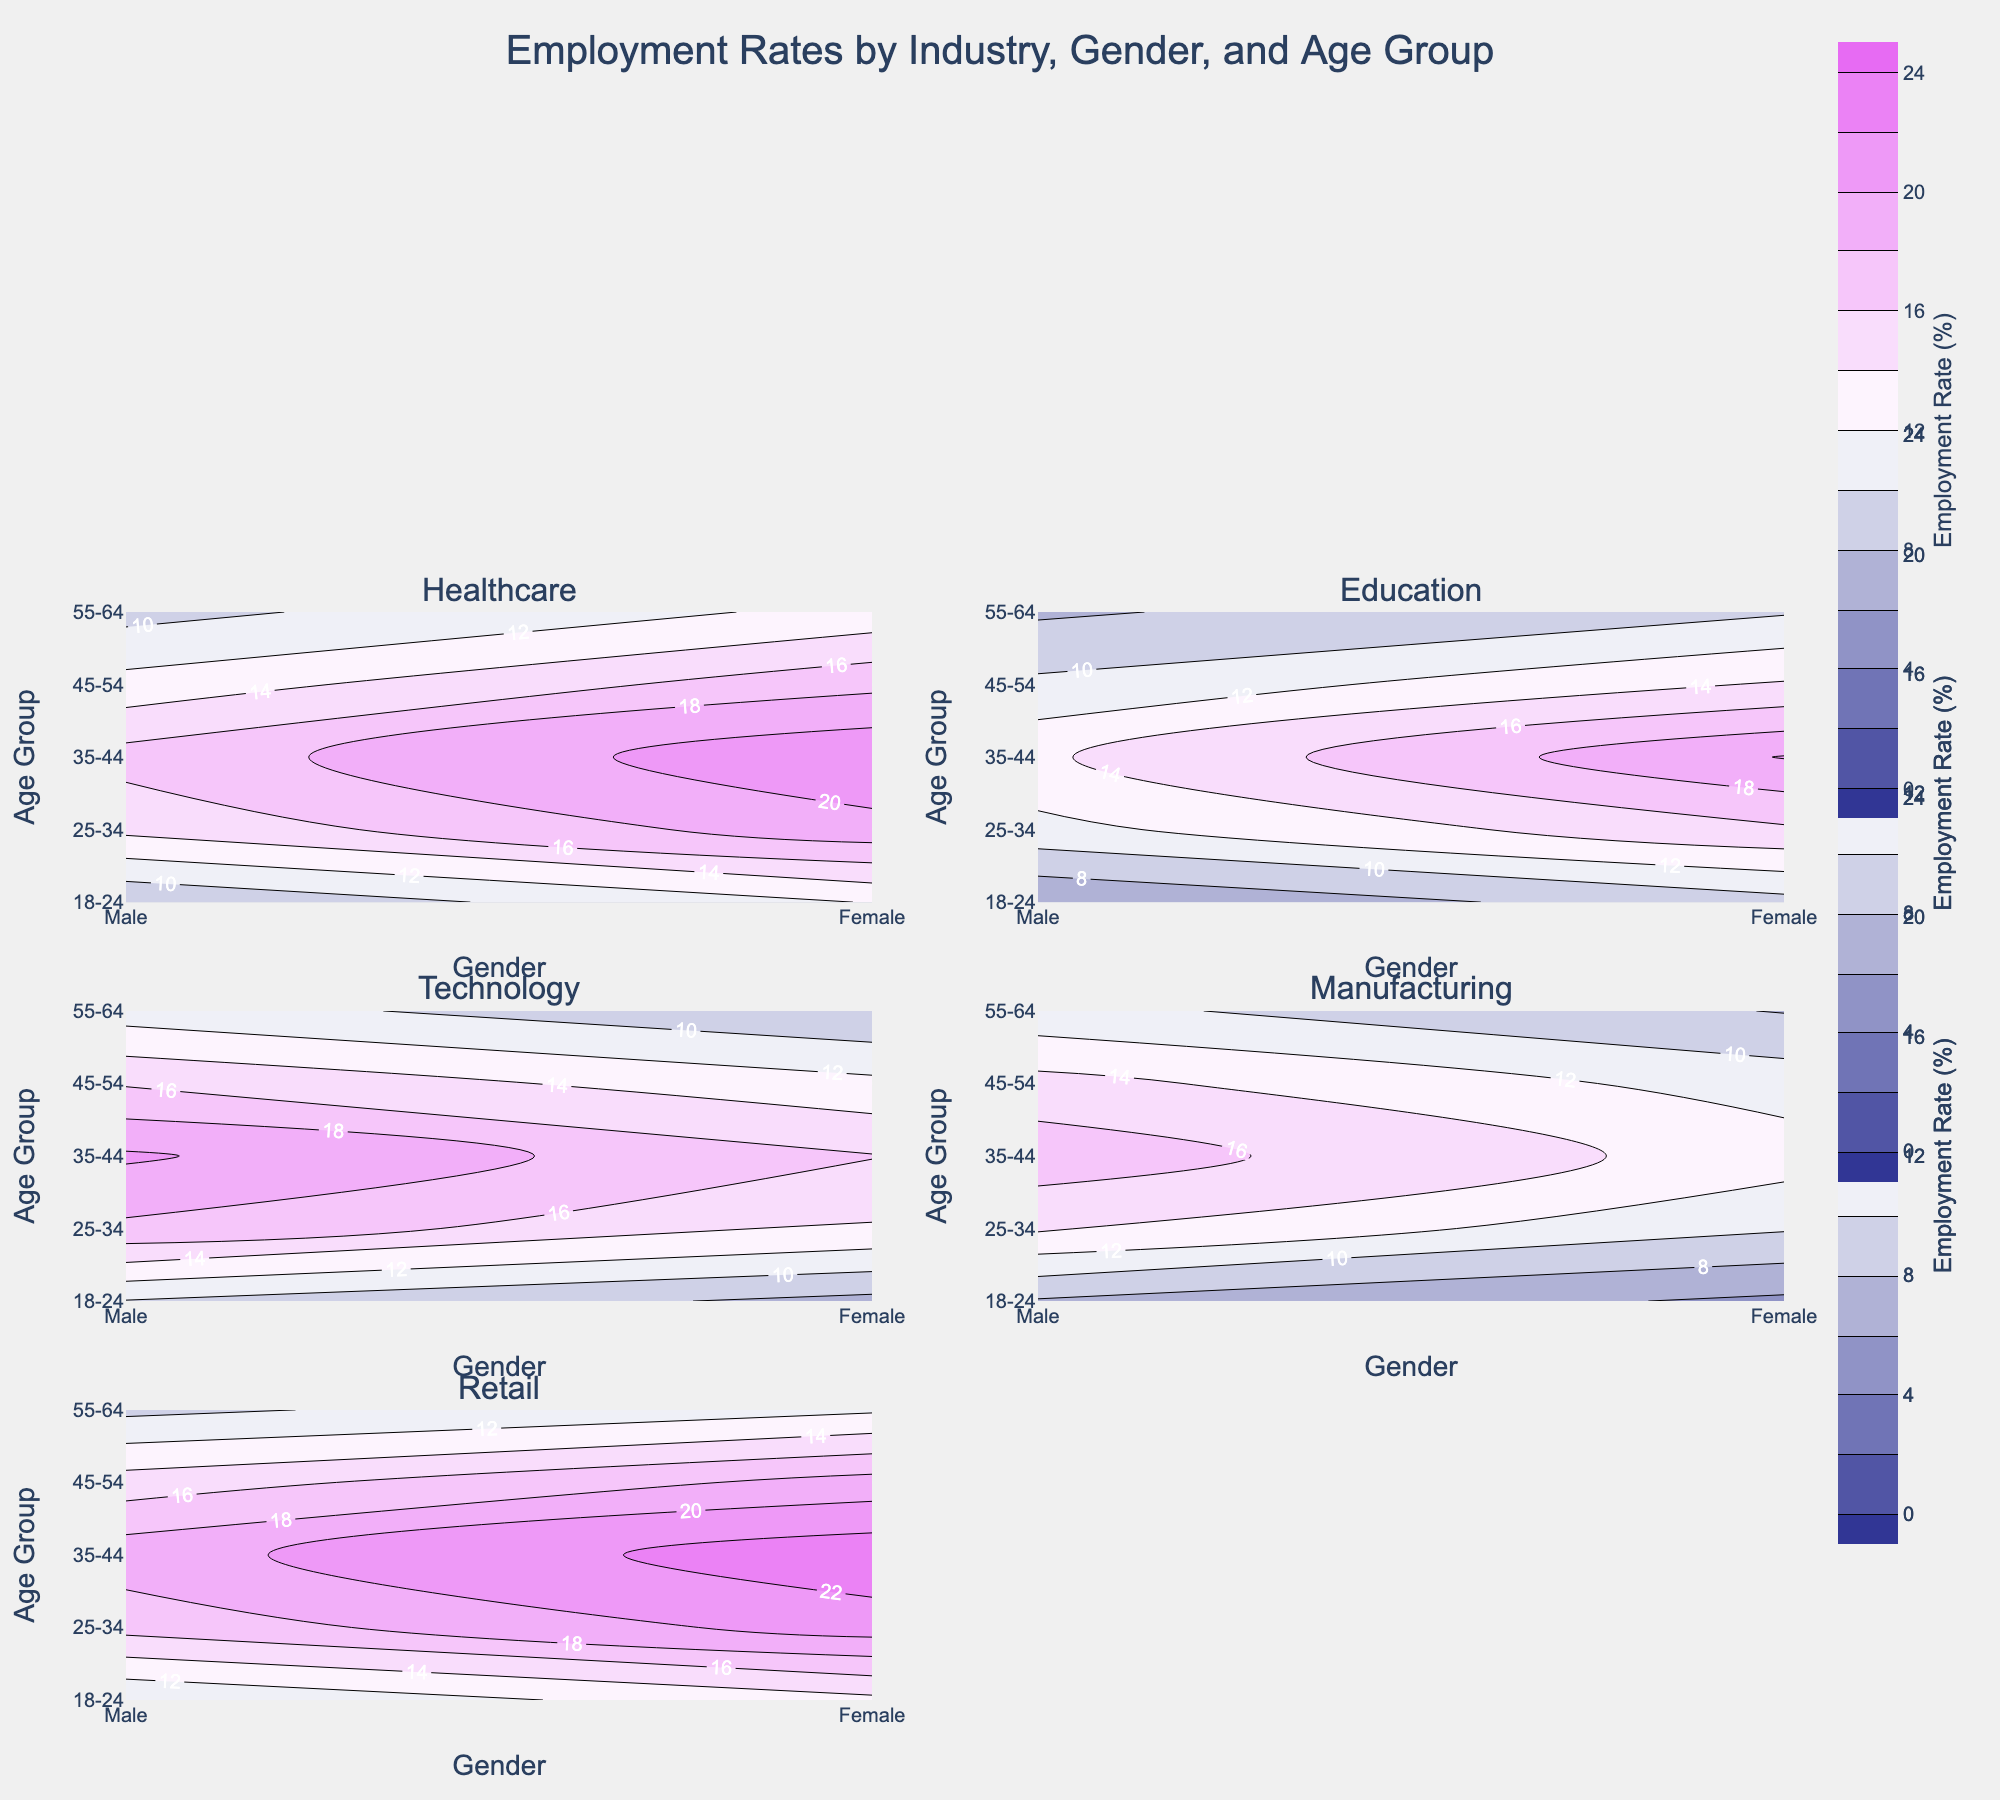How many age groups are displayed for each industry? The figure has five age groups labeled on the y-axis: 18-24, 25-34, 35-44, 45-54, and 55-64. Each subplot representing an industry shows these age groups for both genders.
Answer: 5 Which industry has the highest employment rate for females in the 35-44 age group? In the subplot for each industry, the contour showing the 35-44 age group and female gender shows the employment rate. The highest rate for this group is in the Retail industry where the employment rate for females is 23.4%.
Answer: Retail Which gender generally has a higher employment rate in Healthcare across all age groups? By comparing the contours for males and females across all age groups in the healthcare subplot, females consistently show higher employment rates than males.
Answer: Female Is the employment rate for males in the 25-34 age group higher in Technology or Manufacturing? Checking the contours for males in the 25-34 age group in the Technology and Manufacturing subplots, Technology has a rate of 17.6% while Manufacturing has a rate of 14.3%. Technology's rate is higher.
Answer: Technology What is the employment rate for males aged 45-54 in Education? In the Education subplot, for the age group of 45-54 and gender male, the employment rate can be read from the contour, which is 10.4%.
Answer: 10.4% Are there any industries where males aged 55-64 have lower employment rates than females of the same age group? By comparing the contours for the 55-64 age group, males, and females for each industry, it is observed that in both Technology and Manufacturing, males have a lower employment rate (11.0% vs. 8.1% in Technology and 10.6% vs. 7.9% in Manufacturing).
Answer: Yes Which industry shows the largest difference in employment rates between males and females aged 18-24? The difference can be calculated for each industry by subtracting the employment rate of males from females for the 18-24 age group. Retail shows the largest difference, with females having a rate of 13.5% and males 10.1%, making a difference of 3.4%.
Answer: Retail What is the lowest employment rate observed in the Healthcare industry for any gender-age group combination? In the Healthcare subplot, the lowest employment rate can be found by examining all gender and age group combinations. The lowest observed is for males aged 18-24 at 8.2%.
Answer: 8.2% In the Retail industry, compare the employment rates for females aged 25-34 and males aged 35-44. Which has a higher rate? Reviewing the contours in the Retail subplot for females aged 25-34 and males aged 35-44, females aged 25-34 have a rate of 21.0%, whereas males aged 35-44 have a rate of 19.2%. The female rate is higher.
Answer: Females aged 25-34 